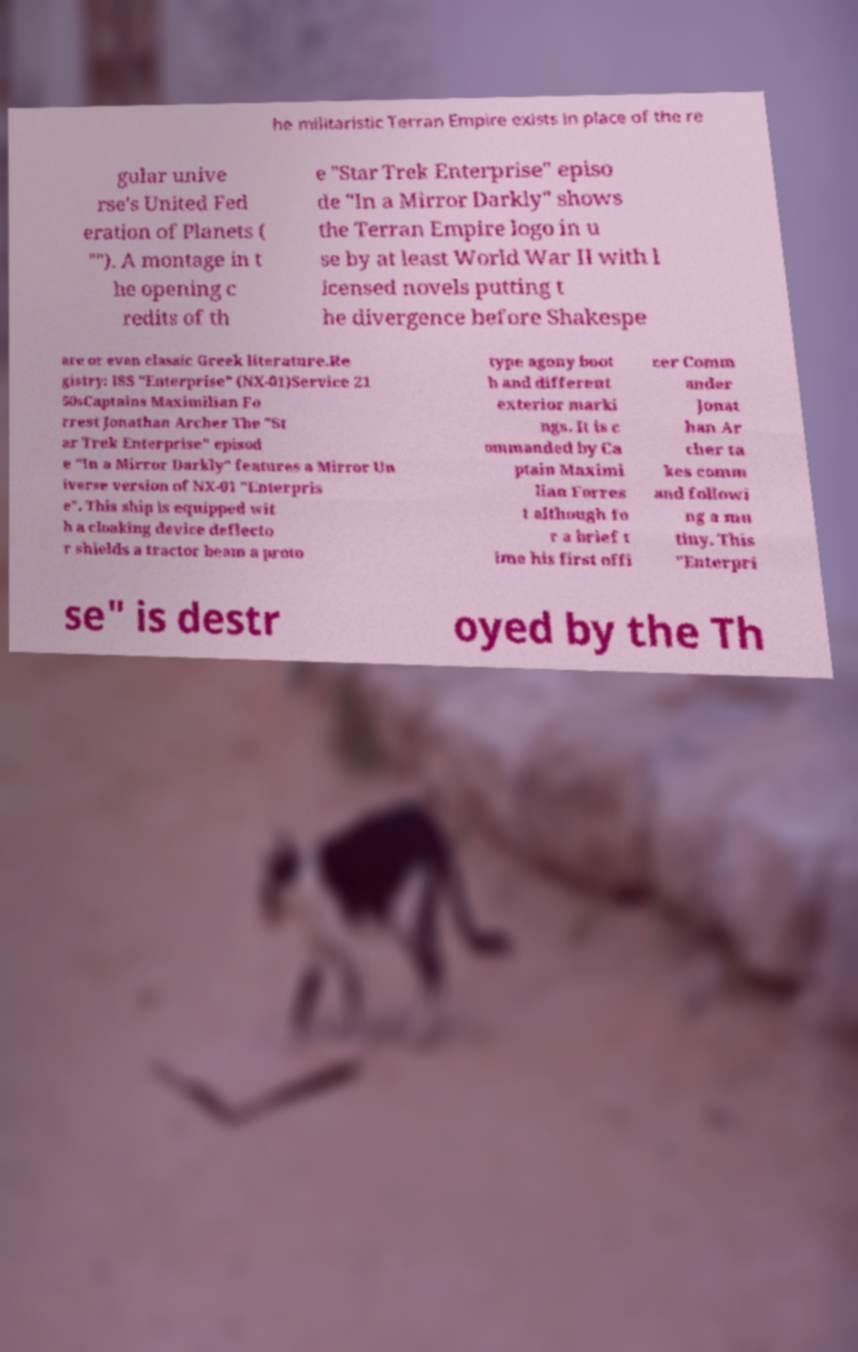For documentation purposes, I need the text within this image transcribed. Could you provide that? he militaristic Terran Empire exists in place of the re gular unive rse's United Fed eration of Planets ( ""). A montage in t he opening c redits of th e "Star Trek Enterprise" episo de "In a Mirror Darkly" shows the Terran Empire logo in u se by at least World War II with l icensed novels putting t he divergence before Shakespe are or even classic Greek literature.Re gistry: ISS "Enterprise" (NX-01)Service 21 50sCaptains Maximilian Fo rrest Jonathan Archer The "St ar Trek Enterprise" episod e "In a Mirror Darkly" features a Mirror Un iverse version of NX-01 "Enterpris e". This ship is equipped wit h a cloaking device deflecto r shields a tractor beam a proto type agony boot h and different exterior marki ngs. It is c ommanded by Ca ptain Maximi lian Forres t although fo r a brief t ime his first offi cer Comm ander Jonat han Ar cher ta kes comm and followi ng a mu tiny. This "Enterpri se" is destr oyed by the Th 